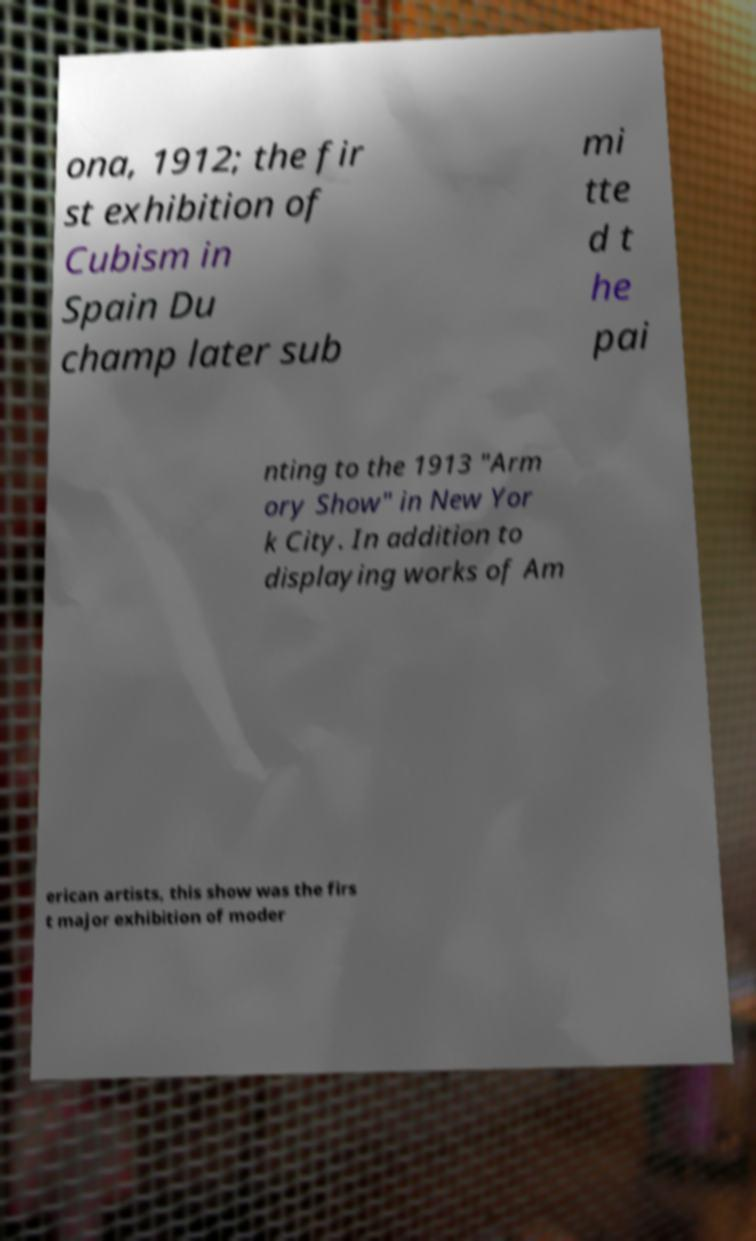Can you accurately transcribe the text from the provided image for me? ona, 1912; the fir st exhibition of Cubism in Spain Du champ later sub mi tte d t he pai nting to the 1913 "Arm ory Show" in New Yor k City. In addition to displaying works of Am erican artists, this show was the firs t major exhibition of moder 